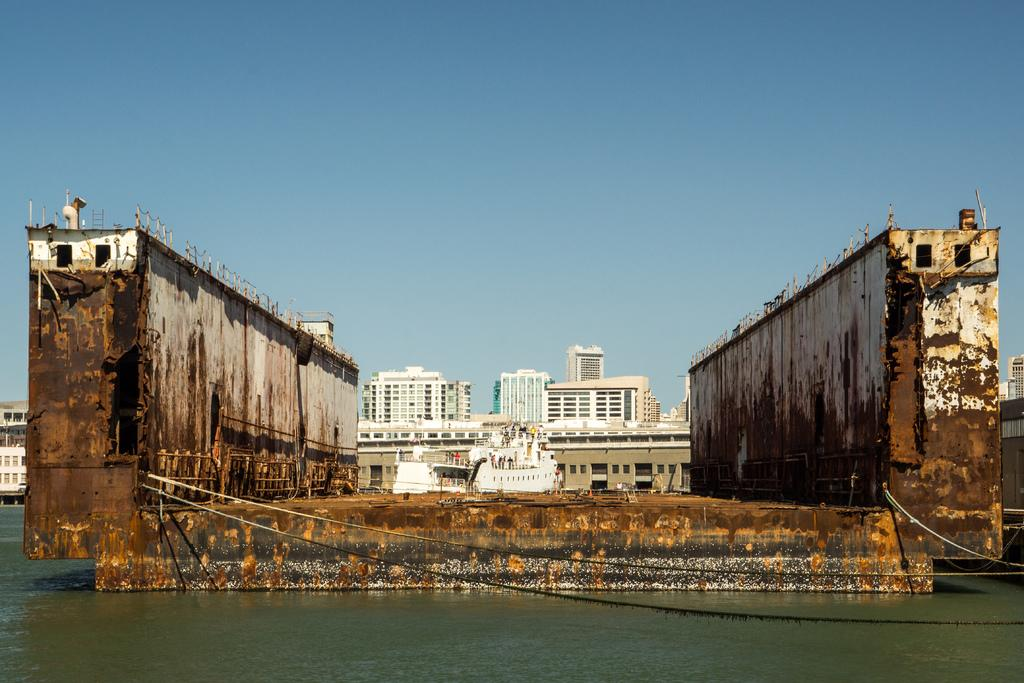What type of structures can be seen in the image? There are buildings in the image. What other objects are present in the image? There are ships in the image. What natural element is visible in the image? Water is visible in the image. What part of the environment is also visible? The sky is visible in the image. What type of attraction can be seen in the image? There is no specific attraction mentioned or visible in the image; it features buildings, ships, water, and the sky. 